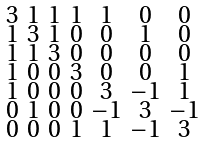Convert formula to latex. <formula><loc_0><loc_0><loc_500><loc_500>\begin{smallmatrix} 3 & 1 & 1 & 1 & 1 & 0 & 0 \\ 1 & 3 & 1 & 0 & 0 & 1 & 0 \\ 1 & 1 & 3 & 0 & 0 & 0 & 0 \\ 1 & 0 & 0 & 3 & 0 & 0 & 1 \\ 1 & 0 & 0 & 0 & 3 & - 1 & 1 \\ 0 & 1 & 0 & 0 & - 1 & 3 & - 1 \\ 0 & 0 & 0 & 1 & 1 & - 1 & 3 \end{smallmatrix}</formula> 